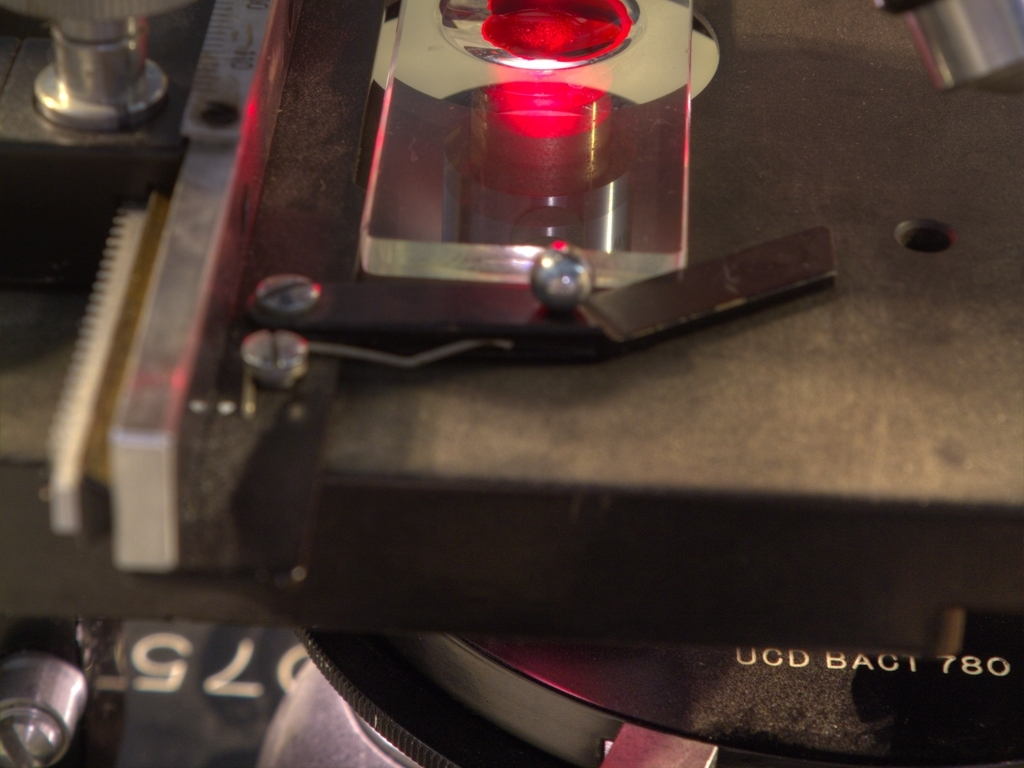What types of environments do you think this instrument is used in? Instruments like the one in the image are typically found in controlled environments such as research laboratories or manufacturing facilities where precision measurements are crucial. What kind of subjects or materials might be analyzed with this instrument? It could be used to analyze a broad range of subjects, such as biological samples, industrial materials, or chemical compounds, depending on the specific setup and capabilities. 